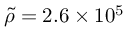<formula> <loc_0><loc_0><loc_500><loc_500>\tilde { \rho } = 2 . 6 \times 1 0 ^ { 5 }</formula> 